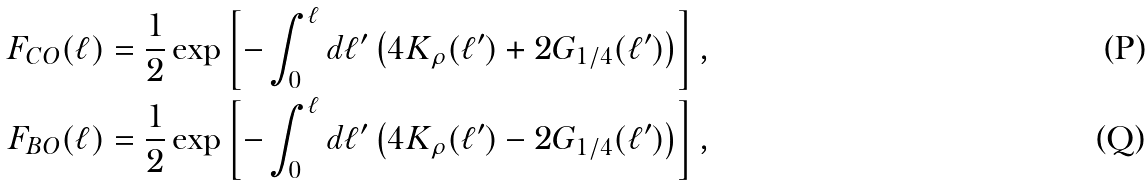Convert formula to latex. <formula><loc_0><loc_0><loc_500><loc_500>F _ { C O } ( \ell ) & = \frac { 1 } { 2 } \exp \left [ - \int _ { 0 } ^ { \ell } d \ell ^ { \prime } \left ( 4 K _ { \rho } ( \ell ^ { \prime } ) + 2 G _ { 1 / 4 } ( \ell ^ { \prime } ) \right ) \right ] , \\ F _ { B O } ( \ell ) & = \frac { 1 } { 2 } \exp \left [ - \int _ { 0 } ^ { \ell } d \ell ^ { \prime } \left ( 4 K _ { \rho } ( \ell ^ { \prime } ) - 2 G _ { 1 / 4 } ( \ell ^ { \prime } ) \right ) \right ] ,</formula> 